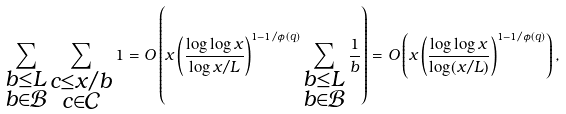Convert formula to latex. <formula><loc_0><loc_0><loc_500><loc_500>\sum _ { \substack { b \leq L \\ b \in \mathcal { B } } } \sum _ { \substack { c \leq x / b \\ c \in \mathcal { C } } } 1 = O \left ( x \left ( \frac { \log \log x } { \log x / L } \right ) ^ { 1 - 1 / \phi ( q ) } \sum _ { \substack { b \leq L \\ b \in \mathcal { B } } } \frac { 1 } { b } \right ) = O \left ( x \left ( \frac { \log \log x } { \log ( x / L ) } \right ) ^ { 1 - 1 / \phi ( q ) } \right ) ,</formula> 